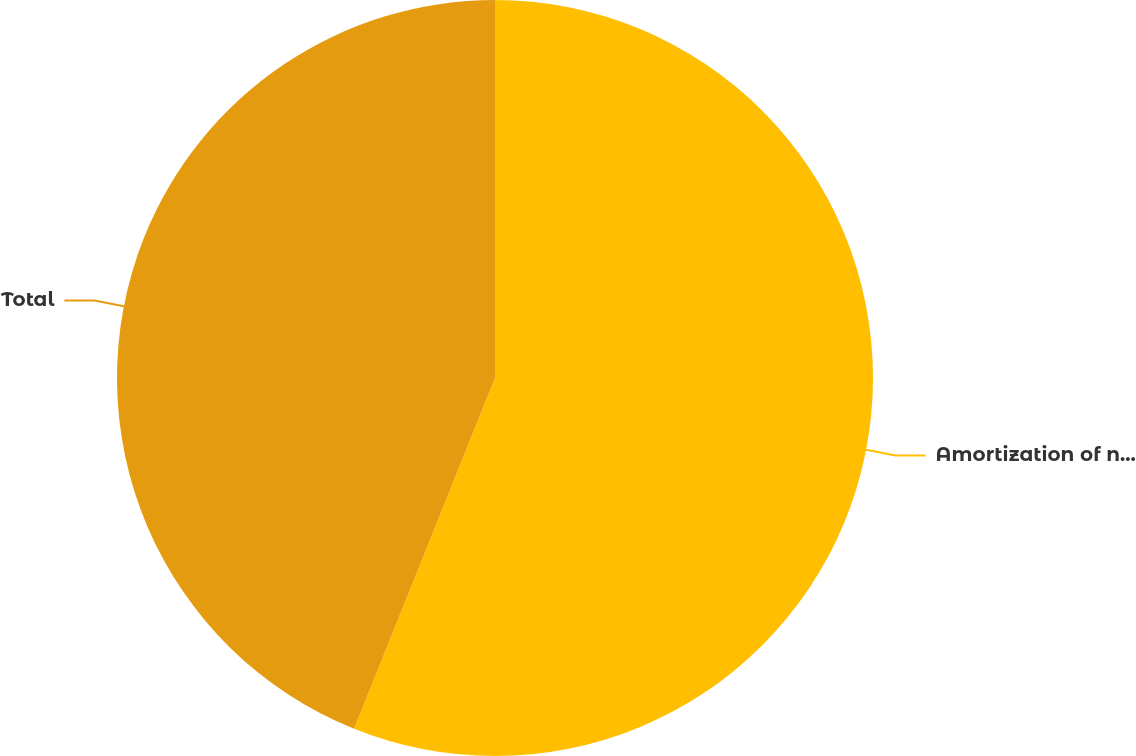Convert chart. <chart><loc_0><loc_0><loc_500><loc_500><pie_chart><fcel>Amortization of net actuarial<fcel>Total<nl><fcel>56.08%<fcel>43.92%<nl></chart> 